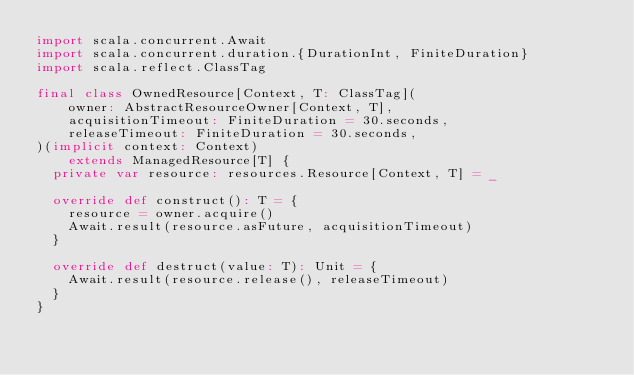<code> <loc_0><loc_0><loc_500><loc_500><_Scala_>import scala.concurrent.Await
import scala.concurrent.duration.{DurationInt, FiniteDuration}
import scala.reflect.ClassTag

final class OwnedResource[Context, T: ClassTag](
    owner: AbstractResourceOwner[Context, T],
    acquisitionTimeout: FiniteDuration = 30.seconds,
    releaseTimeout: FiniteDuration = 30.seconds,
)(implicit context: Context)
    extends ManagedResource[T] {
  private var resource: resources.Resource[Context, T] = _

  override def construct(): T = {
    resource = owner.acquire()
    Await.result(resource.asFuture, acquisitionTimeout)
  }

  override def destruct(value: T): Unit = {
    Await.result(resource.release(), releaseTimeout)
  }
}
</code> 